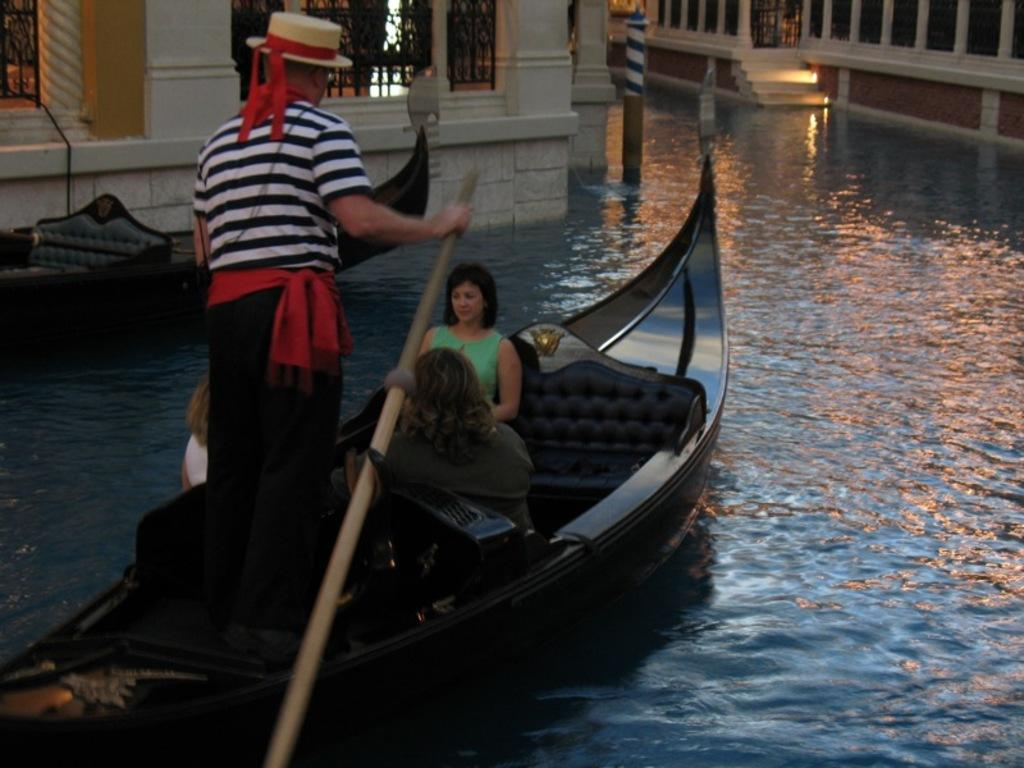What is the primary element in the image? There is water in the image. What is on the water in the image? There are boats on the water. Who or what is in the boats? There are people in the boats. What can be seen in the background of the image? There are buildings in the background of the image. What sound can be heard coming from the moon in the image? There is no moon present in the image, and therefore no sound can be heard coming from it. 